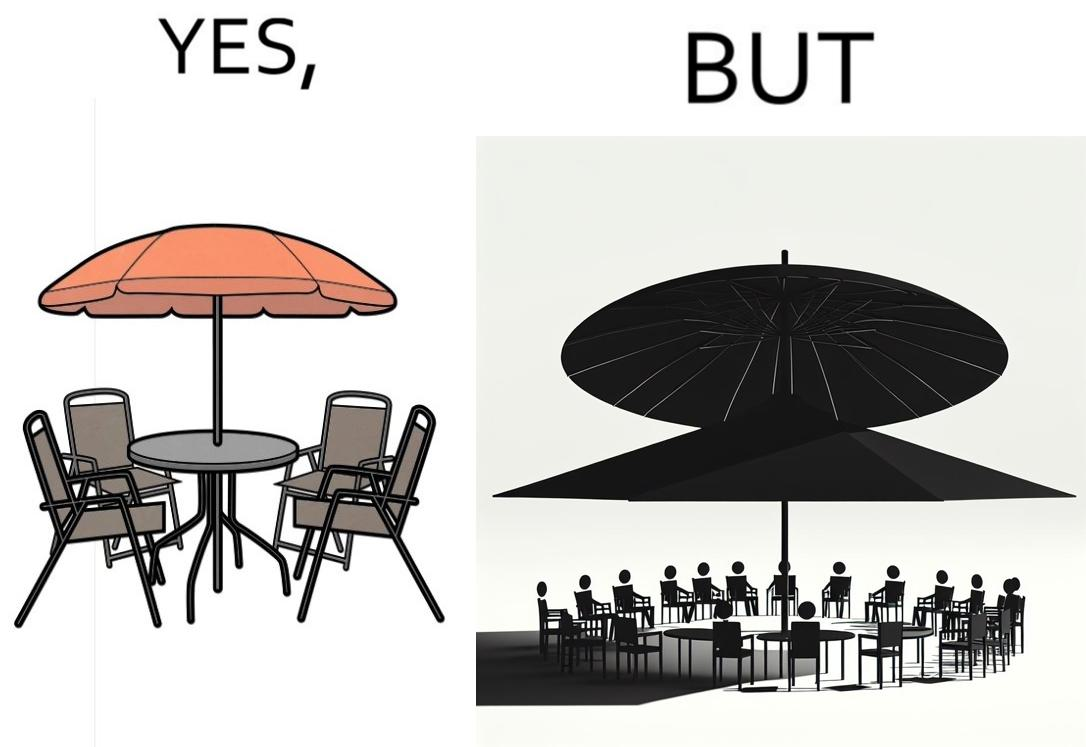Is this a satirical image? Yes, this image is satirical. 